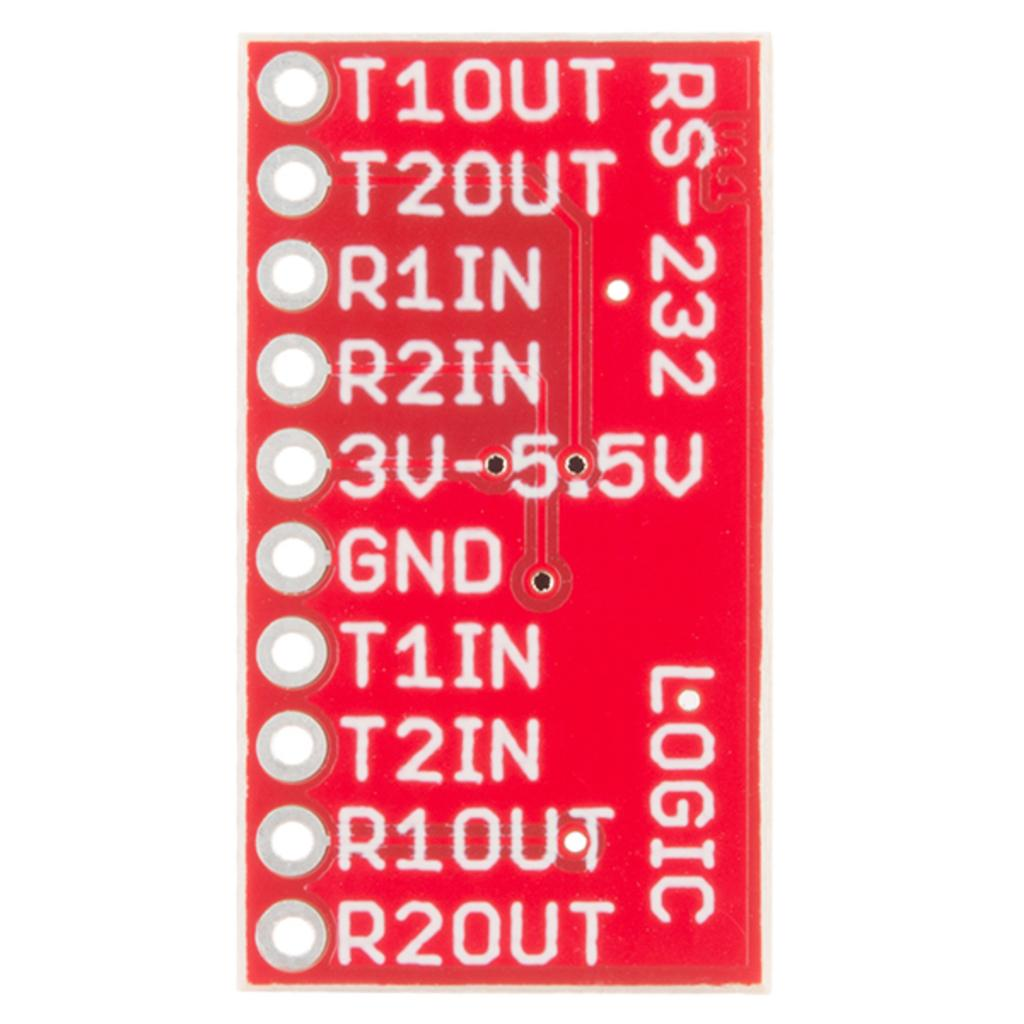<image>
Render a clear and concise summary of the photo. A close up of a red Logic circuit board with numbered terminals. 